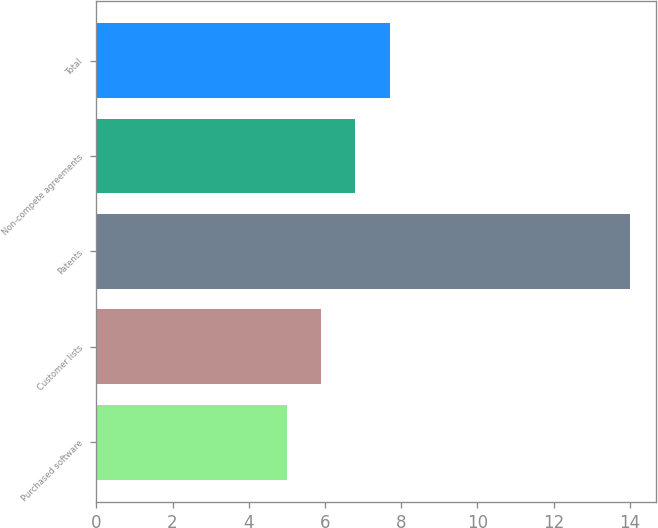Convert chart. <chart><loc_0><loc_0><loc_500><loc_500><bar_chart><fcel>Purchased software<fcel>Customer lists<fcel>Patents<fcel>Non-compete agreements<fcel>Total<nl><fcel>5<fcel>5.9<fcel>14<fcel>6.8<fcel>7.7<nl></chart> 